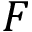<formula> <loc_0><loc_0><loc_500><loc_500>F</formula> 